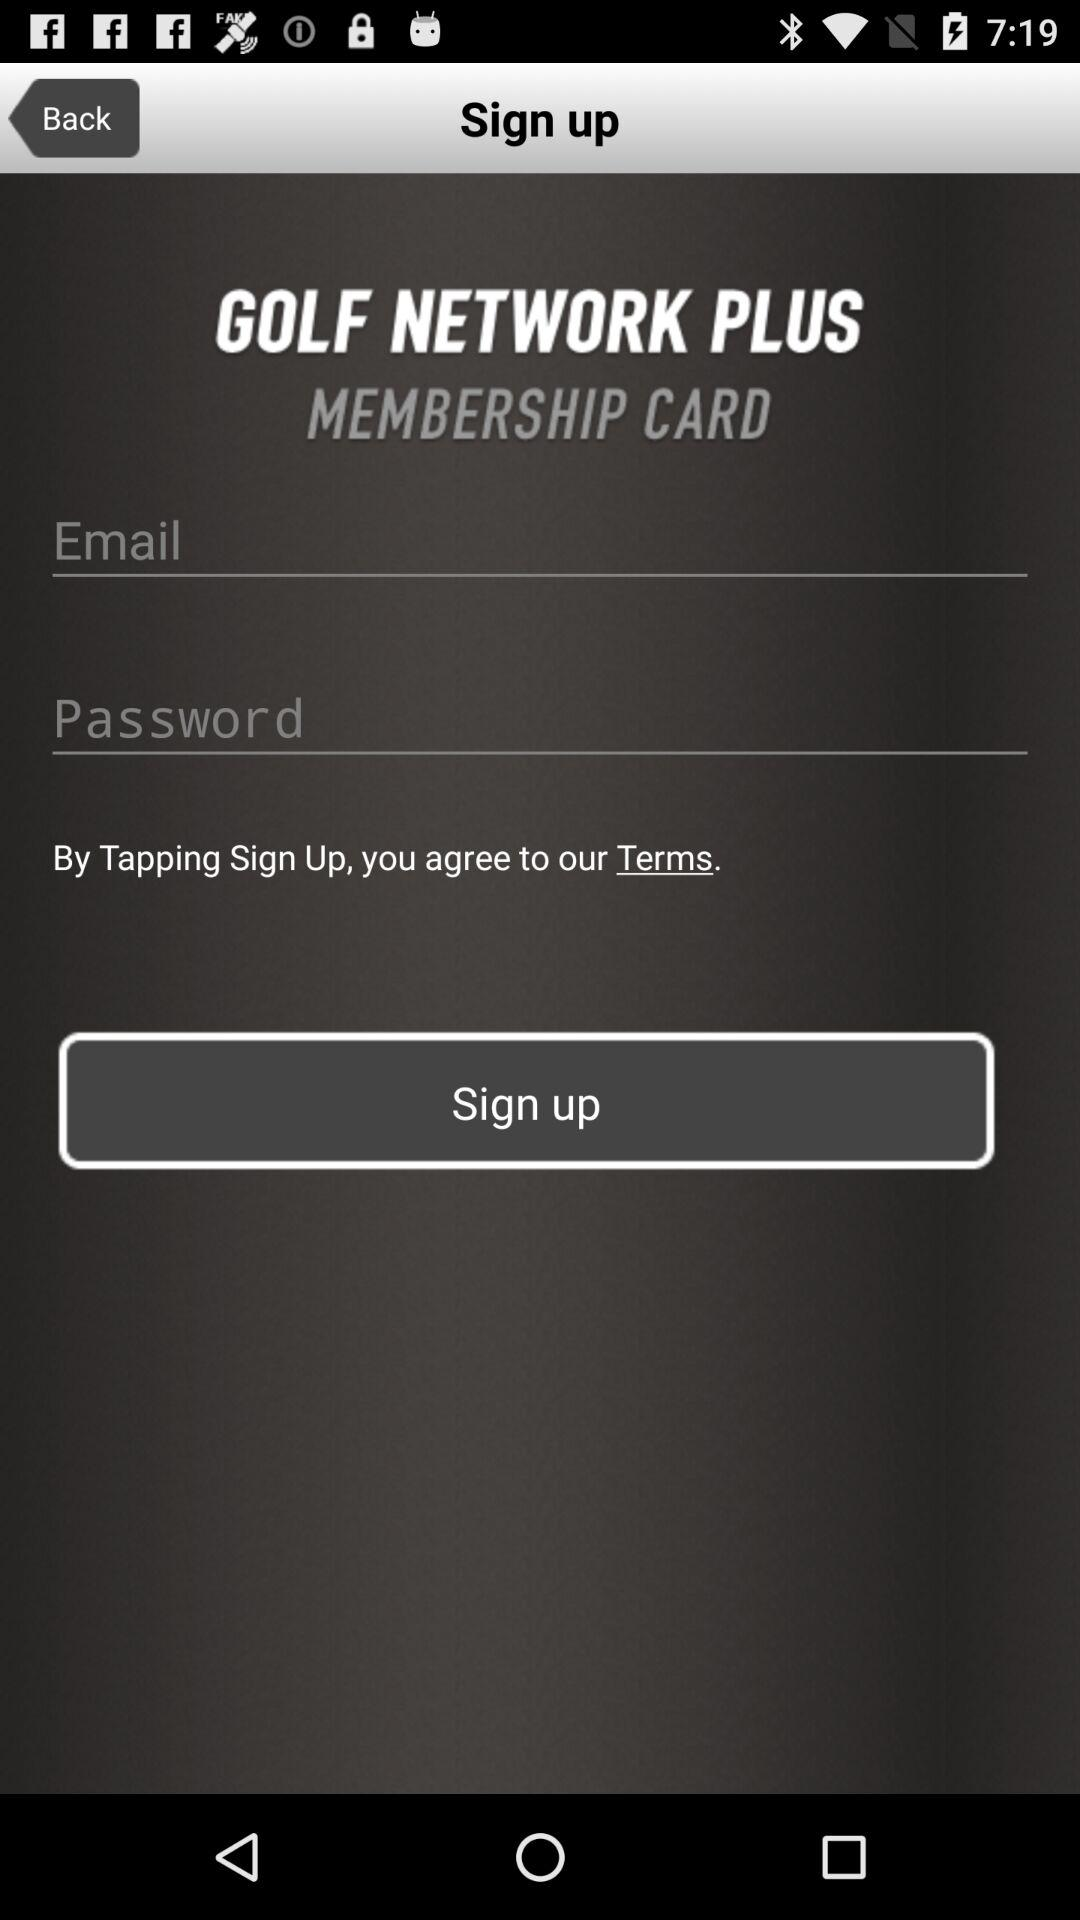What is the name of the application? The name of the application is "GOLF NETWORK PLUS". 